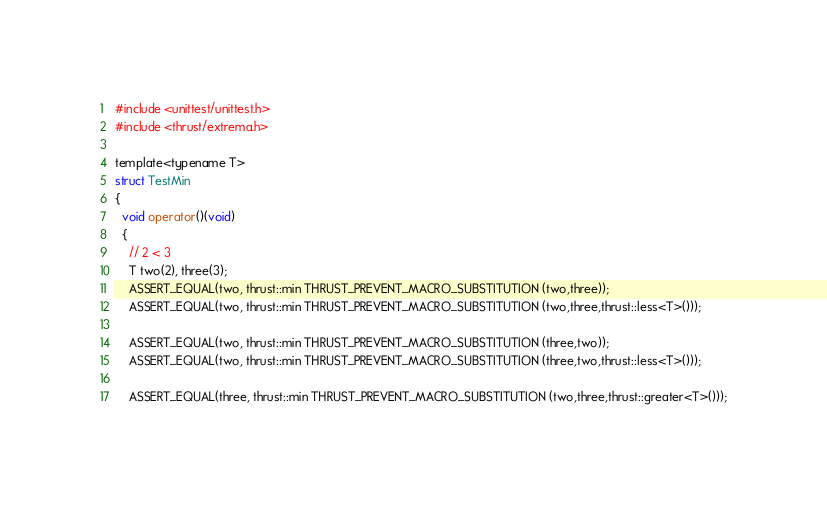Convert code to text. <code><loc_0><loc_0><loc_500><loc_500><_Cuda_>#include <unittest/unittest.h>
#include <thrust/extrema.h>

template<typename T>
struct TestMin
{
  void operator()(void)
  {
    // 2 < 3
    T two(2), three(3);
    ASSERT_EQUAL(two, thrust::min THRUST_PREVENT_MACRO_SUBSTITUTION (two,three));
    ASSERT_EQUAL(two, thrust::min THRUST_PREVENT_MACRO_SUBSTITUTION (two,three,thrust::less<T>()));

    ASSERT_EQUAL(two, thrust::min THRUST_PREVENT_MACRO_SUBSTITUTION (three,two));
    ASSERT_EQUAL(two, thrust::min THRUST_PREVENT_MACRO_SUBSTITUTION (three,two,thrust::less<T>()));

    ASSERT_EQUAL(three, thrust::min THRUST_PREVENT_MACRO_SUBSTITUTION (two,three,thrust::greater<T>()));</code> 